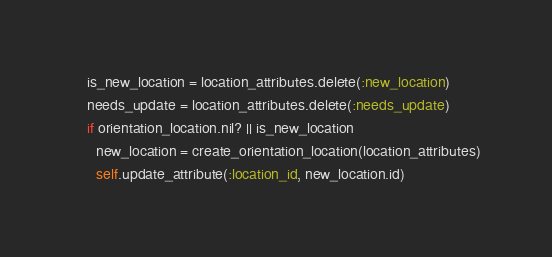<code> <loc_0><loc_0><loc_500><loc_500><_Ruby_>    is_new_location = location_attributes.delete(:new_location)
    needs_update = location_attributes.delete(:needs_update)
    if orientation_location.nil? || is_new_location
      new_location = create_orientation_location(location_attributes)
      self.update_attribute(:location_id, new_location.id)</code> 